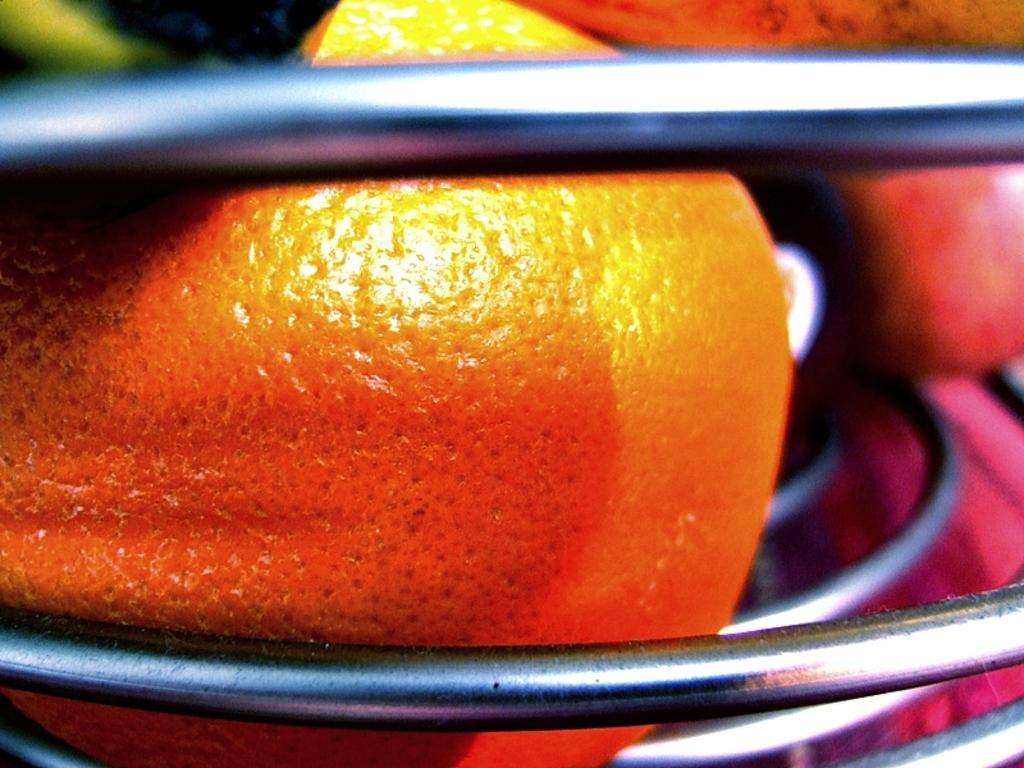What type of food can be seen in the image? There are fruits in the image. How are the fruits arranged or contained in the image? The fruits are in a bowl. What type of patch is visible on the fruits in the image? There is no patch visible on the fruits in the image; the image only shows fruits in a bowl. 